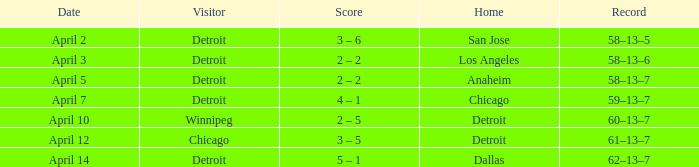What is the date of the game that had a visitor of Chicago? April 12. 